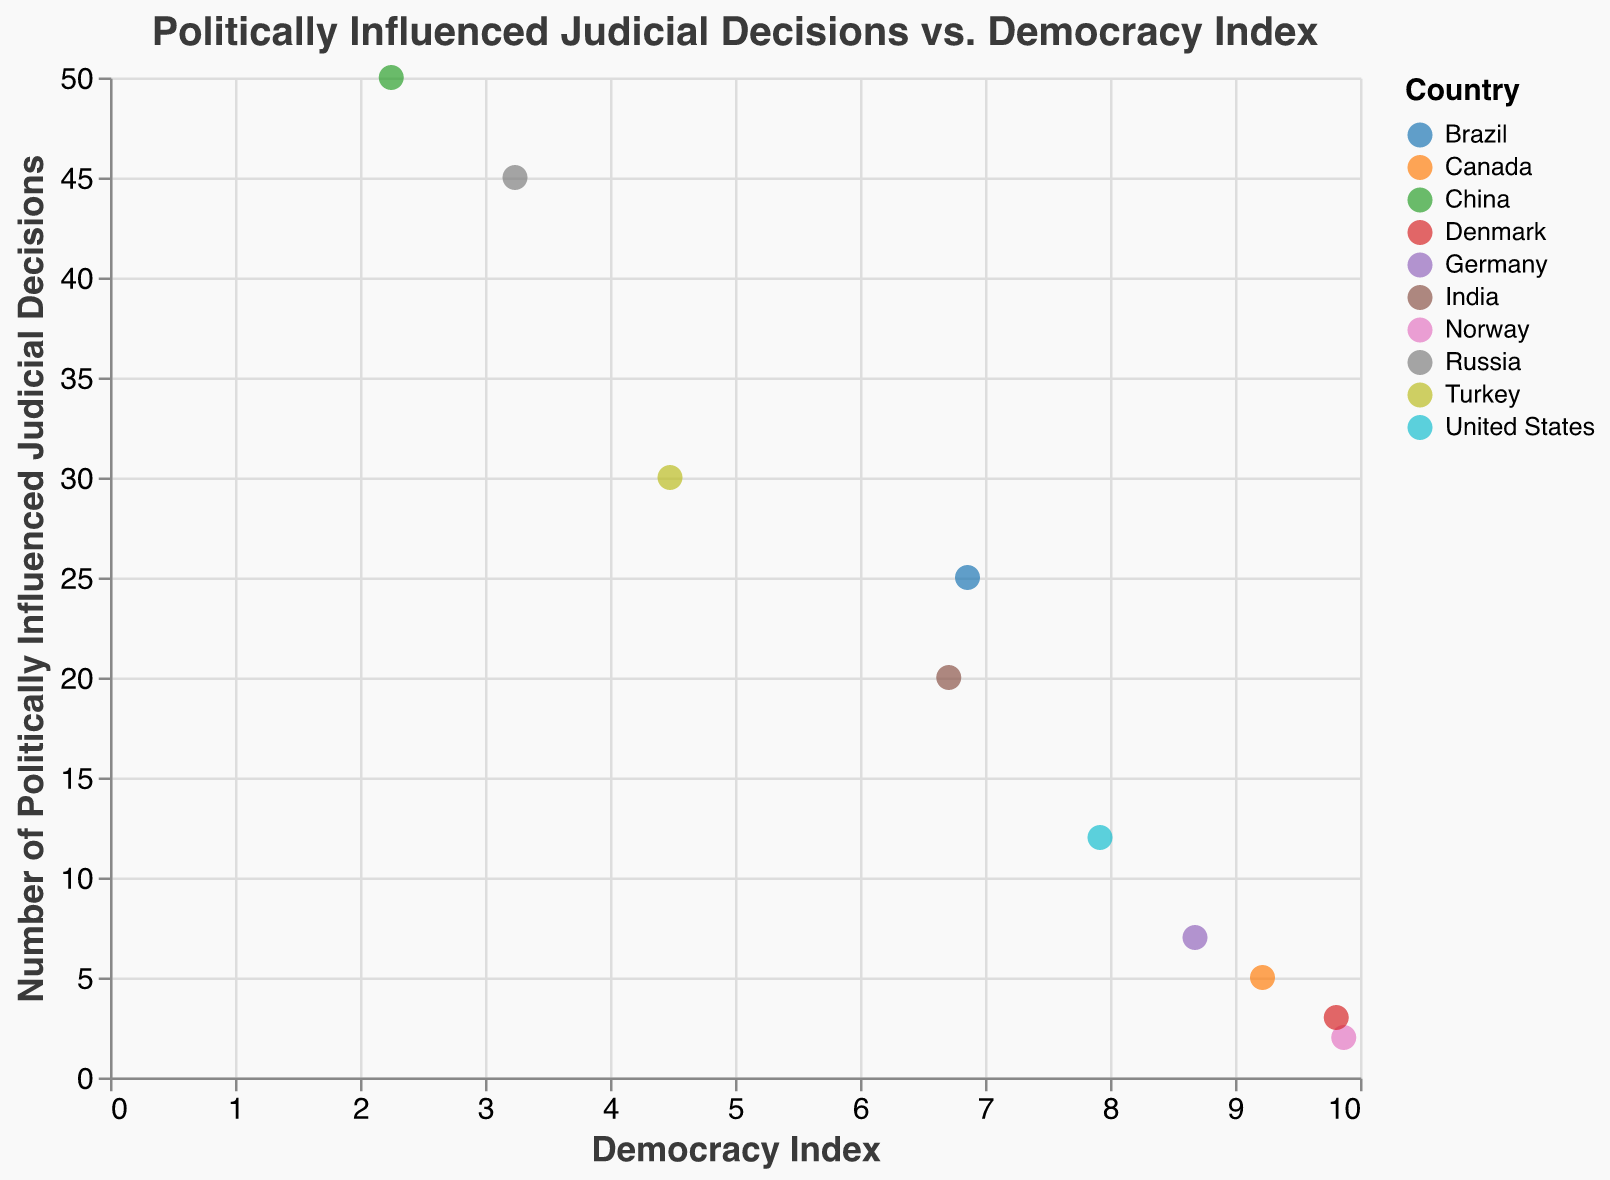What is the title of the scatter plot? The title of the scatter plot is placed at the top of the figure. It reads "Politically Influenced Judicial Decisions vs. Democracy Index".
Answer: Politically Influenced Judicial Decisions vs. Democracy Index Which country has the highest number of politically influenced judicial decisions? By looking at the 'Number of Politically Influenced Judicial Decisions' axis, the data point representing the highest value is China, with 50 decisions.
Answer: China What is the Democracy Index of Germany? Germany is represented by a specific data point on the graph. By hovering over the data point or referring to the plotted values, we see that Germany's Democracy Index is 8.68.
Answer: 8.68 How many countries have a Democracy Index higher than 7? By inspecting the data points plotted along the x-axis, the countries with a Democracy Index higher than 7 are Norway, Denmark, Canada, Germany, and the United States, making a total of 5 countries.
Answer: 5 Which country has both a high Democracy Index and a relatively low number of politically influenced judicial decisions? By looking at the upper left quadrant of the scatter plot, we see that Norway and Denmark both have high Democracy Indexes close to 10 and low numbers of politically influenced judicial decisions (2 and 3, respectively).
Answer: Norway and Denmark What is the trend between the Democracy Index and the Number of Politically Influenced Judicial Decisions? By observing the scatter plot, there is an inverse relationship between the Democracy Index and the Number of Politically Influenced Judicial Decisions. As the Democracy Index increases, the Number of Politically Influenced Judicial Decisions tends to decrease.
Answer: Inverse Which country has the closest Democracy Index to 5? By examining the x-axis, we see that the country with the Democracy Index closest to 5 is Turkey, with a Democracy Index of 4.48.
Answer: Turkey Compare the number of politically influenced judicial decisions between India and Brazil. Which country has more? By referring to the y-axis values, India has 20 politically influenced judicial decisions while Brazil has 25. Therefore, Brazil has more.
Answer: Brazil What is the Democracy Index range of the countries plotted? The minimum and maximum values along the x-axis provide the range, with China having the lowest value of 2.25 and Norway the highest at 9.87.
Answer: 2.25 to 9.87 On average, do countries with a lower Democracy Index have more politically influenced judicial decisions as compared to countries with a higher Democracy Index? By considering the overall distribution and trend in the plot, it appears that countries with lower Democracy Indexes generally have more politically influenced judicial decisions compared to countries with higher Democracy Indexes.
Answer: Yes 